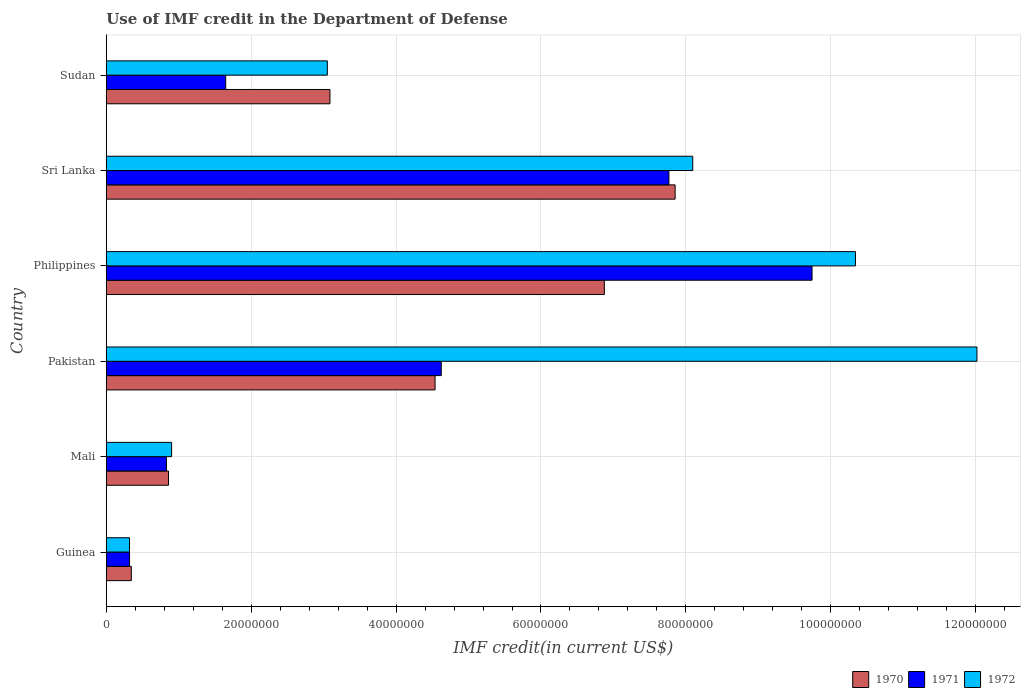How many groups of bars are there?
Offer a very short reply. 6. How many bars are there on the 2nd tick from the top?
Offer a very short reply. 3. What is the IMF credit in the Department of Defense in 1972 in Philippines?
Give a very brief answer. 1.03e+08. Across all countries, what is the maximum IMF credit in the Department of Defense in 1970?
Your response must be concise. 7.85e+07. Across all countries, what is the minimum IMF credit in the Department of Defense in 1972?
Provide a short and direct response. 3.20e+06. In which country was the IMF credit in the Department of Defense in 1972 minimum?
Give a very brief answer. Guinea. What is the total IMF credit in the Department of Defense in 1970 in the graph?
Provide a succinct answer. 2.36e+08. What is the difference between the IMF credit in the Department of Defense in 1972 in Guinea and that in Mali?
Ensure brevity in your answer.  -5.81e+06. What is the difference between the IMF credit in the Department of Defense in 1970 in Sri Lanka and the IMF credit in the Department of Defense in 1971 in Pakistan?
Make the answer very short. 3.23e+07. What is the average IMF credit in the Department of Defense in 1970 per country?
Offer a very short reply. 3.93e+07. What is the difference between the IMF credit in the Department of Defense in 1972 and IMF credit in the Department of Defense in 1971 in Mali?
Ensure brevity in your answer.  7.16e+05. What is the ratio of the IMF credit in the Department of Defense in 1972 in Mali to that in Sudan?
Provide a succinct answer. 0.3. Is the difference between the IMF credit in the Department of Defense in 1972 in Mali and Sudan greater than the difference between the IMF credit in the Department of Defense in 1971 in Mali and Sudan?
Your answer should be compact. No. What is the difference between the highest and the second highest IMF credit in the Department of Defense in 1972?
Offer a very short reply. 1.68e+07. What is the difference between the highest and the lowest IMF credit in the Department of Defense in 1970?
Offer a very short reply. 7.51e+07. In how many countries, is the IMF credit in the Department of Defense in 1970 greater than the average IMF credit in the Department of Defense in 1970 taken over all countries?
Your answer should be very brief. 3. What does the 3rd bar from the bottom in Pakistan represents?
Keep it short and to the point. 1972. How many bars are there?
Give a very brief answer. 18. Are all the bars in the graph horizontal?
Your response must be concise. Yes. How many countries are there in the graph?
Your answer should be very brief. 6. Are the values on the major ticks of X-axis written in scientific E-notation?
Offer a terse response. No. Does the graph contain any zero values?
Offer a terse response. No. How many legend labels are there?
Provide a short and direct response. 3. What is the title of the graph?
Your answer should be compact. Use of IMF credit in the Department of Defense. What is the label or title of the X-axis?
Give a very brief answer. IMF credit(in current US$). What is the label or title of the Y-axis?
Offer a very short reply. Country. What is the IMF credit(in current US$) in 1970 in Guinea?
Offer a terse response. 3.45e+06. What is the IMF credit(in current US$) of 1971 in Guinea?
Make the answer very short. 3.20e+06. What is the IMF credit(in current US$) of 1972 in Guinea?
Offer a terse response. 3.20e+06. What is the IMF credit(in current US$) in 1970 in Mali?
Make the answer very short. 8.58e+06. What is the IMF credit(in current US$) of 1971 in Mali?
Your answer should be compact. 8.30e+06. What is the IMF credit(in current US$) in 1972 in Mali?
Give a very brief answer. 9.01e+06. What is the IMF credit(in current US$) of 1970 in Pakistan?
Ensure brevity in your answer.  4.54e+07. What is the IMF credit(in current US$) of 1971 in Pakistan?
Offer a terse response. 4.62e+07. What is the IMF credit(in current US$) of 1972 in Pakistan?
Give a very brief answer. 1.20e+08. What is the IMF credit(in current US$) of 1970 in Philippines?
Your response must be concise. 6.88e+07. What is the IMF credit(in current US$) in 1971 in Philippines?
Make the answer very short. 9.74e+07. What is the IMF credit(in current US$) in 1972 in Philippines?
Give a very brief answer. 1.03e+08. What is the IMF credit(in current US$) of 1970 in Sri Lanka?
Your answer should be very brief. 7.85e+07. What is the IMF credit(in current US$) of 1971 in Sri Lanka?
Give a very brief answer. 7.77e+07. What is the IMF credit(in current US$) in 1972 in Sri Lanka?
Your answer should be compact. 8.10e+07. What is the IMF credit(in current US$) in 1970 in Sudan?
Offer a terse response. 3.09e+07. What is the IMF credit(in current US$) of 1971 in Sudan?
Make the answer very short. 1.65e+07. What is the IMF credit(in current US$) of 1972 in Sudan?
Offer a terse response. 3.05e+07. Across all countries, what is the maximum IMF credit(in current US$) in 1970?
Your answer should be compact. 7.85e+07. Across all countries, what is the maximum IMF credit(in current US$) of 1971?
Offer a terse response. 9.74e+07. Across all countries, what is the maximum IMF credit(in current US$) of 1972?
Ensure brevity in your answer.  1.20e+08. Across all countries, what is the minimum IMF credit(in current US$) in 1970?
Your answer should be very brief. 3.45e+06. Across all countries, what is the minimum IMF credit(in current US$) of 1971?
Make the answer very short. 3.20e+06. Across all countries, what is the minimum IMF credit(in current US$) of 1972?
Your response must be concise. 3.20e+06. What is the total IMF credit(in current US$) of 1970 in the graph?
Make the answer very short. 2.36e+08. What is the total IMF credit(in current US$) in 1971 in the graph?
Provide a succinct answer. 2.49e+08. What is the total IMF credit(in current US$) in 1972 in the graph?
Ensure brevity in your answer.  3.47e+08. What is the difference between the IMF credit(in current US$) in 1970 in Guinea and that in Mali?
Provide a short and direct response. -5.13e+06. What is the difference between the IMF credit(in current US$) of 1971 in Guinea and that in Mali?
Give a very brief answer. -5.09e+06. What is the difference between the IMF credit(in current US$) in 1972 in Guinea and that in Mali?
Ensure brevity in your answer.  -5.81e+06. What is the difference between the IMF credit(in current US$) in 1970 in Guinea and that in Pakistan?
Keep it short and to the point. -4.19e+07. What is the difference between the IMF credit(in current US$) of 1971 in Guinea and that in Pakistan?
Provide a succinct answer. -4.30e+07. What is the difference between the IMF credit(in current US$) of 1972 in Guinea and that in Pakistan?
Offer a very short reply. -1.17e+08. What is the difference between the IMF credit(in current US$) in 1970 in Guinea and that in Philippines?
Give a very brief answer. -6.53e+07. What is the difference between the IMF credit(in current US$) in 1971 in Guinea and that in Philippines?
Your response must be concise. -9.42e+07. What is the difference between the IMF credit(in current US$) of 1972 in Guinea and that in Philippines?
Provide a succinct answer. -1.00e+08. What is the difference between the IMF credit(in current US$) in 1970 in Guinea and that in Sri Lanka?
Keep it short and to the point. -7.51e+07. What is the difference between the IMF credit(in current US$) in 1971 in Guinea and that in Sri Lanka?
Offer a very short reply. -7.45e+07. What is the difference between the IMF credit(in current US$) of 1972 in Guinea and that in Sri Lanka?
Provide a succinct answer. -7.77e+07. What is the difference between the IMF credit(in current US$) of 1970 in Guinea and that in Sudan?
Give a very brief answer. -2.74e+07. What is the difference between the IMF credit(in current US$) of 1971 in Guinea and that in Sudan?
Give a very brief answer. -1.33e+07. What is the difference between the IMF credit(in current US$) of 1972 in Guinea and that in Sudan?
Keep it short and to the point. -2.73e+07. What is the difference between the IMF credit(in current US$) of 1970 in Mali and that in Pakistan?
Offer a very short reply. -3.68e+07. What is the difference between the IMF credit(in current US$) of 1971 in Mali and that in Pakistan?
Your response must be concise. -3.79e+07. What is the difference between the IMF credit(in current US$) in 1972 in Mali and that in Pakistan?
Offer a terse response. -1.11e+08. What is the difference between the IMF credit(in current US$) in 1970 in Mali and that in Philippines?
Offer a very short reply. -6.02e+07. What is the difference between the IMF credit(in current US$) of 1971 in Mali and that in Philippines?
Your response must be concise. -8.91e+07. What is the difference between the IMF credit(in current US$) in 1972 in Mali and that in Philippines?
Provide a short and direct response. -9.44e+07. What is the difference between the IMF credit(in current US$) in 1970 in Mali and that in Sri Lanka?
Make the answer very short. -6.99e+07. What is the difference between the IMF credit(in current US$) in 1971 in Mali and that in Sri Lanka?
Make the answer very short. -6.94e+07. What is the difference between the IMF credit(in current US$) of 1972 in Mali and that in Sri Lanka?
Ensure brevity in your answer.  -7.19e+07. What is the difference between the IMF credit(in current US$) of 1970 in Mali and that in Sudan?
Your answer should be very brief. -2.23e+07. What is the difference between the IMF credit(in current US$) in 1971 in Mali and that in Sudan?
Provide a short and direct response. -8.19e+06. What is the difference between the IMF credit(in current US$) of 1972 in Mali and that in Sudan?
Ensure brevity in your answer.  -2.15e+07. What is the difference between the IMF credit(in current US$) of 1970 in Pakistan and that in Philippines?
Your answer should be very brief. -2.34e+07. What is the difference between the IMF credit(in current US$) in 1971 in Pakistan and that in Philippines?
Offer a terse response. -5.12e+07. What is the difference between the IMF credit(in current US$) of 1972 in Pakistan and that in Philippines?
Your response must be concise. 1.68e+07. What is the difference between the IMF credit(in current US$) in 1970 in Pakistan and that in Sri Lanka?
Keep it short and to the point. -3.31e+07. What is the difference between the IMF credit(in current US$) of 1971 in Pakistan and that in Sri Lanka?
Your response must be concise. -3.14e+07. What is the difference between the IMF credit(in current US$) of 1972 in Pakistan and that in Sri Lanka?
Provide a short and direct response. 3.92e+07. What is the difference between the IMF credit(in current US$) in 1970 in Pakistan and that in Sudan?
Give a very brief answer. 1.45e+07. What is the difference between the IMF credit(in current US$) in 1971 in Pakistan and that in Sudan?
Your answer should be very brief. 2.98e+07. What is the difference between the IMF credit(in current US$) of 1972 in Pakistan and that in Sudan?
Provide a short and direct response. 8.97e+07. What is the difference between the IMF credit(in current US$) in 1970 in Philippines and that in Sri Lanka?
Provide a short and direct response. -9.77e+06. What is the difference between the IMF credit(in current US$) in 1971 in Philippines and that in Sri Lanka?
Provide a succinct answer. 1.98e+07. What is the difference between the IMF credit(in current US$) in 1972 in Philippines and that in Sri Lanka?
Offer a very short reply. 2.25e+07. What is the difference between the IMF credit(in current US$) in 1970 in Philippines and that in Sudan?
Your answer should be compact. 3.79e+07. What is the difference between the IMF credit(in current US$) of 1971 in Philippines and that in Sudan?
Offer a very short reply. 8.09e+07. What is the difference between the IMF credit(in current US$) in 1972 in Philippines and that in Sudan?
Give a very brief answer. 7.29e+07. What is the difference between the IMF credit(in current US$) in 1970 in Sri Lanka and that in Sudan?
Your answer should be compact. 4.76e+07. What is the difference between the IMF credit(in current US$) of 1971 in Sri Lanka and that in Sudan?
Offer a terse response. 6.12e+07. What is the difference between the IMF credit(in current US$) of 1972 in Sri Lanka and that in Sudan?
Offer a terse response. 5.04e+07. What is the difference between the IMF credit(in current US$) of 1970 in Guinea and the IMF credit(in current US$) of 1971 in Mali?
Your answer should be very brief. -4.84e+06. What is the difference between the IMF credit(in current US$) of 1970 in Guinea and the IMF credit(in current US$) of 1972 in Mali?
Give a very brief answer. -5.56e+06. What is the difference between the IMF credit(in current US$) in 1971 in Guinea and the IMF credit(in current US$) in 1972 in Mali?
Ensure brevity in your answer.  -5.81e+06. What is the difference between the IMF credit(in current US$) in 1970 in Guinea and the IMF credit(in current US$) in 1971 in Pakistan?
Ensure brevity in your answer.  -4.28e+07. What is the difference between the IMF credit(in current US$) of 1970 in Guinea and the IMF credit(in current US$) of 1972 in Pakistan?
Ensure brevity in your answer.  -1.17e+08. What is the difference between the IMF credit(in current US$) in 1971 in Guinea and the IMF credit(in current US$) in 1972 in Pakistan?
Your answer should be compact. -1.17e+08. What is the difference between the IMF credit(in current US$) in 1970 in Guinea and the IMF credit(in current US$) in 1971 in Philippines?
Offer a very short reply. -9.40e+07. What is the difference between the IMF credit(in current US$) of 1970 in Guinea and the IMF credit(in current US$) of 1972 in Philippines?
Your answer should be compact. -1.00e+08. What is the difference between the IMF credit(in current US$) of 1971 in Guinea and the IMF credit(in current US$) of 1972 in Philippines?
Offer a very short reply. -1.00e+08. What is the difference between the IMF credit(in current US$) in 1970 in Guinea and the IMF credit(in current US$) in 1971 in Sri Lanka?
Your response must be concise. -7.42e+07. What is the difference between the IMF credit(in current US$) in 1970 in Guinea and the IMF credit(in current US$) in 1972 in Sri Lanka?
Your answer should be very brief. -7.75e+07. What is the difference between the IMF credit(in current US$) of 1971 in Guinea and the IMF credit(in current US$) of 1972 in Sri Lanka?
Offer a terse response. -7.77e+07. What is the difference between the IMF credit(in current US$) of 1970 in Guinea and the IMF credit(in current US$) of 1971 in Sudan?
Ensure brevity in your answer.  -1.30e+07. What is the difference between the IMF credit(in current US$) in 1970 in Guinea and the IMF credit(in current US$) in 1972 in Sudan?
Provide a succinct answer. -2.71e+07. What is the difference between the IMF credit(in current US$) of 1971 in Guinea and the IMF credit(in current US$) of 1972 in Sudan?
Your answer should be very brief. -2.73e+07. What is the difference between the IMF credit(in current US$) of 1970 in Mali and the IMF credit(in current US$) of 1971 in Pakistan?
Make the answer very short. -3.77e+07. What is the difference between the IMF credit(in current US$) of 1970 in Mali and the IMF credit(in current US$) of 1972 in Pakistan?
Your response must be concise. -1.12e+08. What is the difference between the IMF credit(in current US$) of 1971 in Mali and the IMF credit(in current US$) of 1972 in Pakistan?
Make the answer very short. -1.12e+08. What is the difference between the IMF credit(in current US$) in 1970 in Mali and the IMF credit(in current US$) in 1971 in Philippines?
Keep it short and to the point. -8.88e+07. What is the difference between the IMF credit(in current US$) in 1970 in Mali and the IMF credit(in current US$) in 1972 in Philippines?
Offer a very short reply. -9.48e+07. What is the difference between the IMF credit(in current US$) of 1971 in Mali and the IMF credit(in current US$) of 1972 in Philippines?
Your answer should be compact. -9.51e+07. What is the difference between the IMF credit(in current US$) of 1970 in Mali and the IMF credit(in current US$) of 1971 in Sri Lanka?
Provide a short and direct response. -6.91e+07. What is the difference between the IMF credit(in current US$) in 1970 in Mali and the IMF credit(in current US$) in 1972 in Sri Lanka?
Your answer should be very brief. -7.24e+07. What is the difference between the IMF credit(in current US$) in 1971 in Mali and the IMF credit(in current US$) in 1972 in Sri Lanka?
Your answer should be very brief. -7.27e+07. What is the difference between the IMF credit(in current US$) of 1970 in Mali and the IMF credit(in current US$) of 1971 in Sudan?
Make the answer very short. -7.90e+06. What is the difference between the IMF credit(in current US$) in 1970 in Mali and the IMF credit(in current US$) in 1972 in Sudan?
Your response must be concise. -2.19e+07. What is the difference between the IMF credit(in current US$) in 1971 in Mali and the IMF credit(in current US$) in 1972 in Sudan?
Make the answer very short. -2.22e+07. What is the difference between the IMF credit(in current US$) in 1970 in Pakistan and the IMF credit(in current US$) in 1971 in Philippines?
Give a very brief answer. -5.20e+07. What is the difference between the IMF credit(in current US$) of 1970 in Pakistan and the IMF credit(in current US$) of 1972 in Philippines?
Ensure brevity in your answer.  -5.80e+07. What is the difference between the IMF credit(in current US$) in 1971 in Pakistan and the IMF credit(in current US$) in 1972 in Philippines?
Make the answer very short. -5.72e+07. What is the difference between the IMF credit(in current US$) of 1970 in Pakistan and the IMF credit(in current US$) of 1971 in Sri Lanka?
Offer a very short reply. -3.23e+07. What is the difference between the IMF credit(in current US$) of 1970 in Pakistan and the IMF credit(in current US$) of 1972 in Sri Lanka?
Offer a very short reply. -3.56e+07. What is the difference between the IMF credit(in current US$) in 1971 in Pakistan and the IMF credit(in current US$) in 1972 in Sri Lanka?
Provide a short and direct response. -3.47e+07. What is the difference between the IMF credit(in current US$) in 1970 in Pakistan and the IMF credit(in current US$) in 1971 in Sudan?
Offer a terse response. 2.89e+07. What is the difference between the IMF credit(in current US$) of 1970 in Pakistan and the IMF credit(in current US$) of 1972 in Sudan?
Offer a very short reply. 1.49e+07. What is the difference between the IMF credit(in current US$) in 1971 in Pakistan and the IMF credit(in current US$) in 1972 in Sudan?
Offer a very short reply. 1.57e+07. What is the difference between the IMF credit(in current US$) of 1970 in Philippines and the IMF credit(in current US$) of 1971 in Sri Lanka?
Keep it short and to the point. -8.91e+06. What is the difference between the IMF credit(in current US$) of 1970 in Philippines and the IMF credit(in current US$) of 1972 in Sri Lanka?
Your answer should be compact. -1.22e+07. What is the difference between the IMF credit(in current US$) of 1971 in Philippines and the IMF credit(in current US$) of 1972 in Sri Lanka?
Provide a succinct answer. 1.65e+07. What is the difference between the IMF credit(in current US$) in 1970 in Philippines and the IMF credit(in current US$) in 1971 in Sudan?
Your answer should be very brief. 5.23e+07. What is the difference between the IMF credit(in current US$) of 1970 in Philippines and the IMF credit(in current US$) of 1972 in Sudan?
Give a very brief answer. 3.82e+07. What is the difference between the IMF credit(in current US$) in 1971 in Philippines and the IMF credit(in current US$) in 1972 in Sudan?
Make the answer very short. 6.69e+07. What is the difference between the IMF credit(in current US$) of 1970 in Sri Lanka and the IMF credit(in current US$) of 1971 in Sudan?
Ensure brevity in your answer.  6.20e+07. What is the difference between the IMF credit(in current US$) in 1970 in Sri Lanka and the IMF credit(in current US$) in 1972 in Sudan?
Offer a terse response. 4.80e+07. What is the difference between the IMF credit(in current US$) of 1971 in Sri Lanka and the IMF credit(in current US$) of 1972 in Sudan?
Ensure brevity in your answer.  4.72e+07. What is the average IMF credit(in current US$) in 1970 per country?
Ensure brevity in your answer.  3.93e+07. What is the average IMF credit(in current US$) in 1971 per country?
Your response must be concise. 4.16e+07. What is the average IMF credit(in current US$) in 1972 per country?
Provide a succinct answer. 5.79e+07. What is the difference between the IMF credit(in current US$) of 1970 and IMF credit(in current US$) of 1971 in Guinea?
Your response must be concise. 2.47e+05. What is the difference between the IMF credit(in current US$) in 1970 and IMF credit(in current US$) in 1972 in Guinea?
Your answer should be compact. 2.47e+05. What is the difference between the IMF credit(in current US$) in 1970 and IMF credit(in current US$) in 1971 in Mali?
Provide a succinct answer. 2.85e+05. What is the difference between the IMF credit(in current US$) of 1970 and IMF credit(in current US$) of 1972 in Mali?
Make the answer very short. -4.31e+05. What is the difference between the IMF credit(in current US$) in 1971 and IMF credit(in current US$) in 1972 in Mali?
Ensure brevity in your answer.  -7.16e+05. What is the difference between the IMF credit(in current US$) of 1970 and IMF credit(in current US$) of 1971 in Pakistan?
Give a very brief answer. -8.56e+05. What is the difference between the IMF credit(in current US$) of 1970 and IMF credit(in current US$) of 1972 in Pakistan?
Provide a short and direct response. -7.48e+07. What is the difference between the IMF credit(in current US$) of 1971 and IMF credit(in current US$) of 1972 in Pakistan?
Your response must be concise. -7.40e+07. What is the difference between the IMF credit(in current US$) in 1970 and IMF credit(in current US$) in 1971 in Philippines?
Your answer should be very brief. -2.87e+07. What is the difference between the IMF credit(in current US$) in 1970 and IMF credit(in current US$) in 1972 in Philippines?
Your answer should be compact. -3.47e+07. What is the difference between the IMF credit(in current US$) of 1971 and IMF credit(in current US$) of 1972 in Philippines?
Your response must be concise. -5.99e+06. What is the difference between the IMF credit(in current US$) of 1970 and IMF credit(in current US$) of 1971 in Sri Lanka?
Give a very brief answer. 8.56e+05. What is the difference between the IMF credit(in current US$) in 1970 and IMF credit(in current US$) in 1972 in Sri Lanka?
Give a very brief answer. -2.43e+06. What is the difference between the IMF credit(in current US$) of 1971 and IMF credit(in current US$) of 1972 in Sri Lanka?
Offer a terse response. -3.29e+06. What is the difference between the IMF credit(in current US$) in 1970 and IMF credit(in current US$) in 1971 in Sudan?
Your answer should be compact. 1.44e+07. What is the difference between the IMF credit(in current US$) of 1970 and IMF credit(in current US$) of 1972 in Sudan?
Make the answer very short. 3.62e+05. What is the difference between the IMF credit(in current US$) in 1971 and IMF credit(in current US$) in 1972 in Sudan?
Give a very brief answer. -1.40e+07. What is the ratio of the IMF credit(in current US$) of 1970 in Guinea to that in Mali?
Your response must be concise. 0.4. What is the ratio of the IMF credit(in current US$) in 1971 in Guinea to that in Mali?
Provide a succinct answer. 0.39. What is the ratio of the IMF credit(in current US$) in 1972 in Guinea to that in Mali?
Offer a terse response. 0.36. What is the ratio of the IMF credit(in current US$) of 1970 in Guinea to that in Pakistan?
Provide a succinct answer. 0.08. What is the ratio of the IMF credit(in current US$) of 1971 in Guinea to that in Pakistan?
Offer a very short reply. 0.07. What is the ratio of the IMF credit(in current US$) of 1972 in Guinea to that in Pakistan?
Offer a terse response. 0.03. What is the ratio of the IMF credit(in current US$) in 1970 in Guinea to that in Philippines?
Provide a succinct answer. 0.05. What is the ratio of the IMF credit(in current US$) in 1971 in Guinea to that in Philippines?
Offer a terse response. 0.03. What is the ratio of the IMF credit(in current US$) in 1972 in Guinea to that in Philippines?
Provide a succinct answer. 0.03. What is the ratio of the IMF credit(in current US$) of 1970 in Guinea to that in Sri Lanka?
Your answer should be compact. 0.04. What is the ratio of the IMF credit(in current US$) in 1971 in Guinea to that in Sri Lanka?
Provide a succinct answer. 0.04. What is the ratio of the IMF credit(in current US$) of 1972 in Guinea to that in Sri Lanka?
Provide a succinct answer. 0.04. What is the ratio of the IMF credit(in current US$) in 1970 in Guinea to that in Sudan?
Your answer should be very brief. 0.11. What is the ratio of the IMF credit(in current US$) of 1971 in Guinea to that in Sudan?
Your answer should be compact. 0.19. What is the ratio of the IMF credit(in current US$) of 1972 in Guinea to that in Sudan?
Provide a short and direct response. 0.1. What is the ratio of the IMF credit(in current US$) of 1970 in Mali to that in Pakistan?
Keep it short and to the point. 0.19. What is the ratio of the IMF credit(in current US$) of 1971 in Mali to that in Pakistan?
Offer a very short reply. 0.18. What is the ratio of the IMF credit(in current US$) of 1972 in Mali to that in Pakistan?
Offer a very short reply. 0.07. What is the ratio of the IMF credit(in current US$) in 1970 in Mali to that in Philippines?
Your response must be concise. 0.12. What is the ratio of the IMF credit(in current US$) in 1971 in Mali to that in Philippines?
Provide a short and direct response. 0.09. What is the ratio of the IMF credit(in current US$) of 1972 in Mali to that in Philippines?
Make the answer very short. 0.09. What is the ratio of the IMF credit(in current US$) of 1970 in Mali to that in Sri Lanka?
Your answer should be compact. 0.11. What is the ratio of the IMF credit(in current US$) of 1971 in Mali to that in Sri Lanka?
Offer a very short reply. 0.11. What is the ratio of the IMF credit(in current US$) in 1972 in Mali to that in Sri Lanka?
Offer a very short reply. 0.11. What is the ratio of the IMF credit(in current US$) in 1970 in Mali to that in Sudan?
Make the answer very short. 0.28. What is the ratio of the IMF credit(in current US$) in 1971 in Mali to that in Sudan?
Keep it short and to the point. 0.5. What is the ratio of the IMF credit(in current US$) in 1972 in Mali to that in Sudan?
Provide a succinct answer. 0.3. What is the ratio of the IMF credit(in current US$) of 1970 in Pakistan to that in Philippines?
Keep it short and to the point. 0.66. What is the ratio of the IMF credit(in current US$) in 1971 in Pakistan to that in Philippines?
Your answer should be very brief. 0.47. What is the ratio of the IMF credit(in current US$) in 1972 in Pakistan to that in Philippines?
Offer a terse response. 1.16. What is the ratio of the IMF credit(in current US$) in 1970 in Pakistan to that in Sri Lanka?
Your response must be concise. 0.58. What is the ratio of the IMF credit(in current US$) in 1971 in Pakistan to that in Sri Lanka?
Keep it short and to the point. 0.6. What is the ratio of the IMF credit(in current US$) of 1972 in Pakistan to that in Sri Lanka?
Offer a terse response. 1.48. What is the ratio of the IMF credit(in current US$) of 1970 in Pakistan to that in Sudan?
Your answer should be very brief. 1.47. What is the ratio of the IMF credit(in current US$) in 1971 in Pakistan to that in Sudan?
Your answer should be compact. 2.81. What is the ratio of the IMF credit(in current US$) in 1972 in Pakistan to that in Sudan?
Offer a terse response. 3.94. What is the ratio of the IMF credit(in current US$) in 1970 in Philippines to that in Sri Lanka?
Give a very brief answer. 0.88. What is the ratio of the IMF credit(in current US$) in 1971 in Philippines to that in Sri Lanka?
Offer a terse response. 1.25. What is the ratio of the IMF credit(in current US$) in 1972 in Philippines to that in Sri Lanka?
Offer a terse response. 1.28. What is the ratio of the IMF credit(in current US$) in 1970 in Philippines to that in Sudan?
Give a very brief answer. 2.23. What is the ratio of the IMF credit(in current US$) of 1971 in Philippines to that in Sudan?
Keep it short and to the point. 5.91. What is the ratio of the IMF credit(in current US$) in 1972 in Philippines to that in Sudan?
Offer a terse response. 3.39. What is the ratio of the IMF credit(in current US$) in 1970 in Sri Lanka to that in Sudan?
Provide a succinct answer. 2.54. What is the ratio of the IMF credit(in current US$) of 1971 in Sri Lanka to that in Sudan?
Make the answer very short. 4.71. What is the ratio of the IMF credit(in current US$) of 1972 in Sri Lanka to that in Sudan?
Provide a succinct answer. 2.65. What is the difference between the highest and the second highest IMF credit(in current US$) in 1970?
Provide a short and direct response. 9.77e+06. What is the difference between the highest and the second highest IMF credit(in current US$) of 1971?
Make the answer very short. 1.98e+07. What is the difference between the highest and the second highest IMF credit(in current US$) of 1972?
Give a very brief answer. 1.68e+07. What is the difference between the highest and the lowest IMF credit(in current US$) of 1970?
Ensure brevity in your answer.  7.51e+07. What is the difference between the highest and the lowest IMF credit(in current US$) in 1971?
Your answer should be very brief. 9.42e+07. What is the difference between the highest and the lowest IMF credit(in current US$) in 1972?
Give a very brief answer. 1.17e+08. 